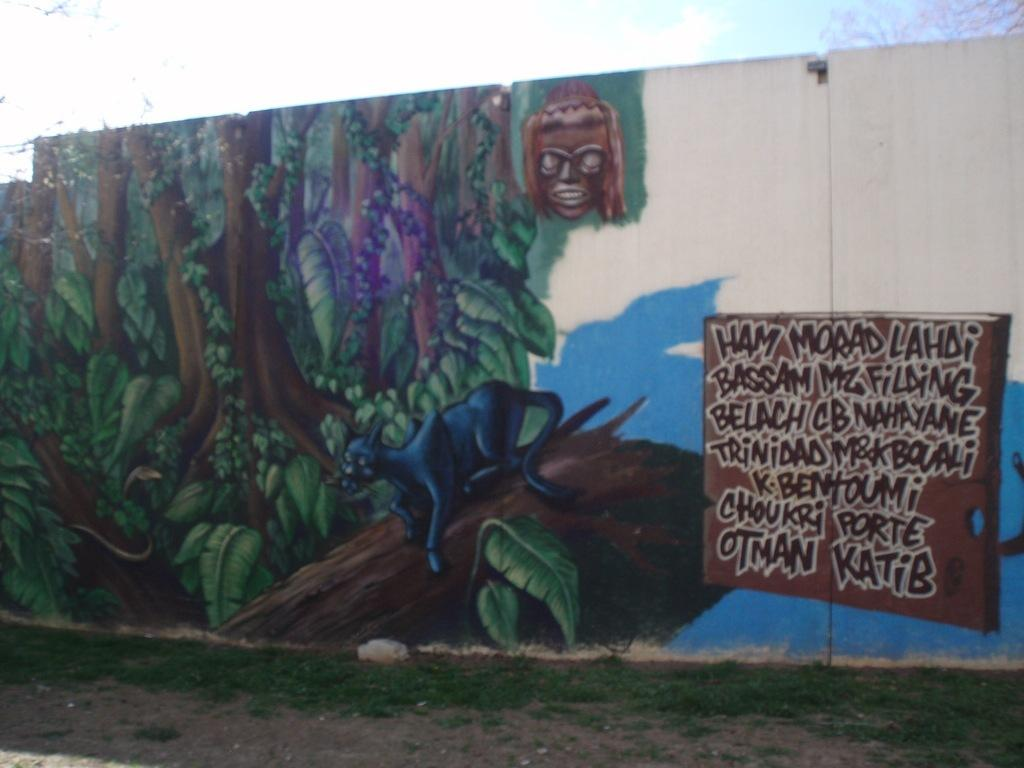What is depicted on the wall in the image? There is a painting on a wall in the image. What type of stone is used to create the bike in the image? There is no bike present in the image; it only features a painting on a wall. 